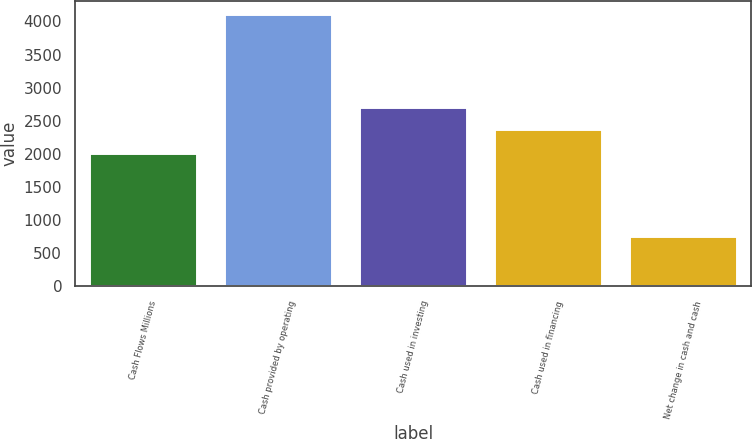Convert chart. <chart><loc_0><loc_0><loc_500><loc_500><bar_chart><fcel>Cash Flows Millions<fcel>Cash provided by operating<fcel>Cash used in investing<fcel>Cash used in financing<fcel>Net change in cash and cash<nl><fcel>2010<fcel>4105<fcel>2715.1<fcel>2381<fcel>764<nl></chart> 